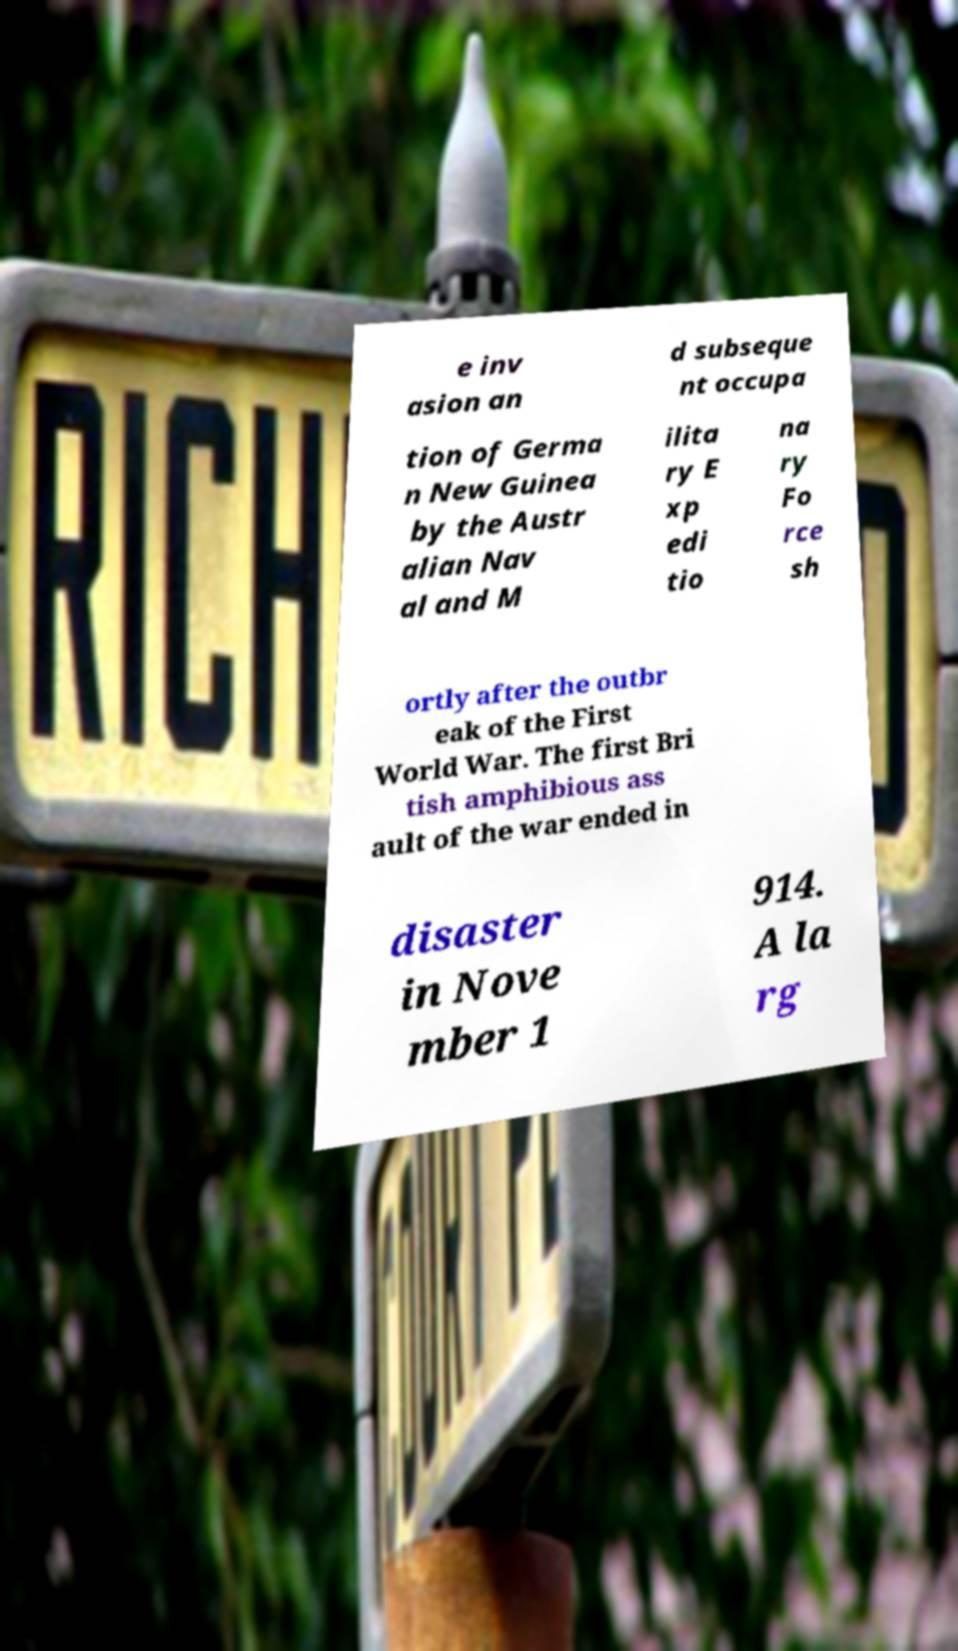Could you assist in decoding the text presented in this image and type it out clearly? e inv asion an d subseque nt occupa tion of Germa n New Guinea by the Austr alian Nav al and M ilita ry E xp edi tio na ry Fo rce sh ortly after the outbr eak of the First World War. The first Bri tish amphibious ass ault of the war ended in disaster in Nove mber 1 914. A la rg 